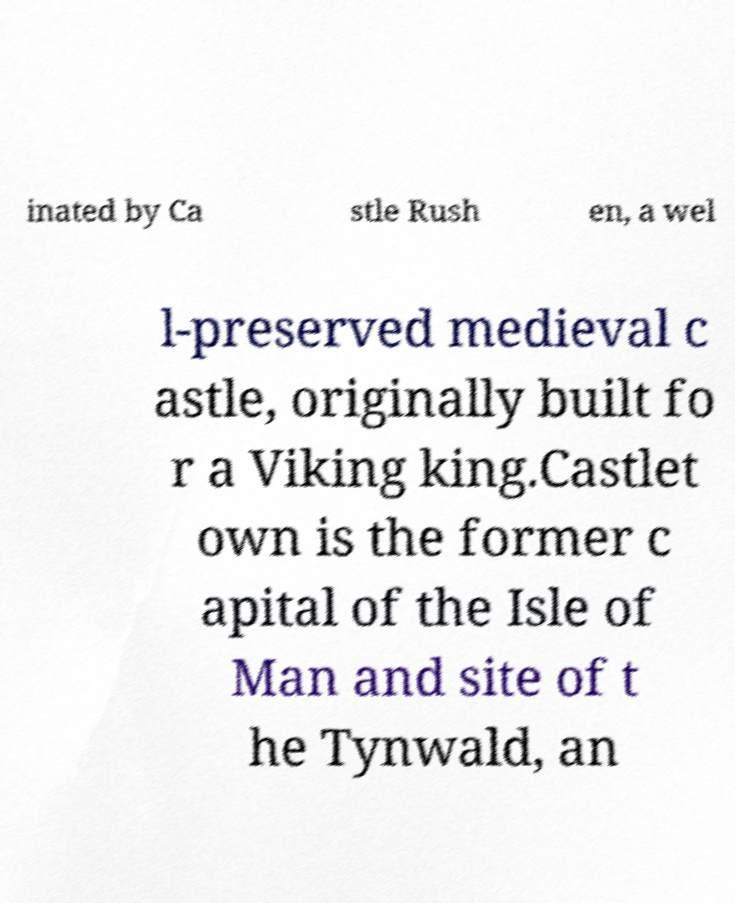I need the written content from this picture converted into text. Can you do that? inated by Ca stle Rush en, a wel l-preserved medieval c astle, originally built fo r a Viking king.Castlet own is the former c apital of the Isle of Man and site of t he Tynwald, an 